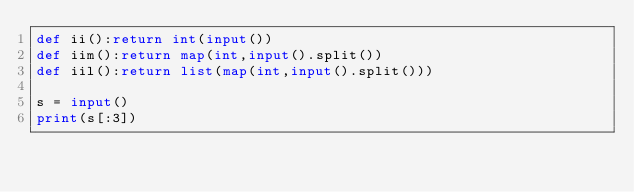Convert code to text. <code><loc_0><loc_0><loc_500><loc_500><_Python_>def ii():return int(input())
def iim():return map(int,input().split())
def iil():return list(map(int,input().split()))

s = input()
print(s[:3])</code> 